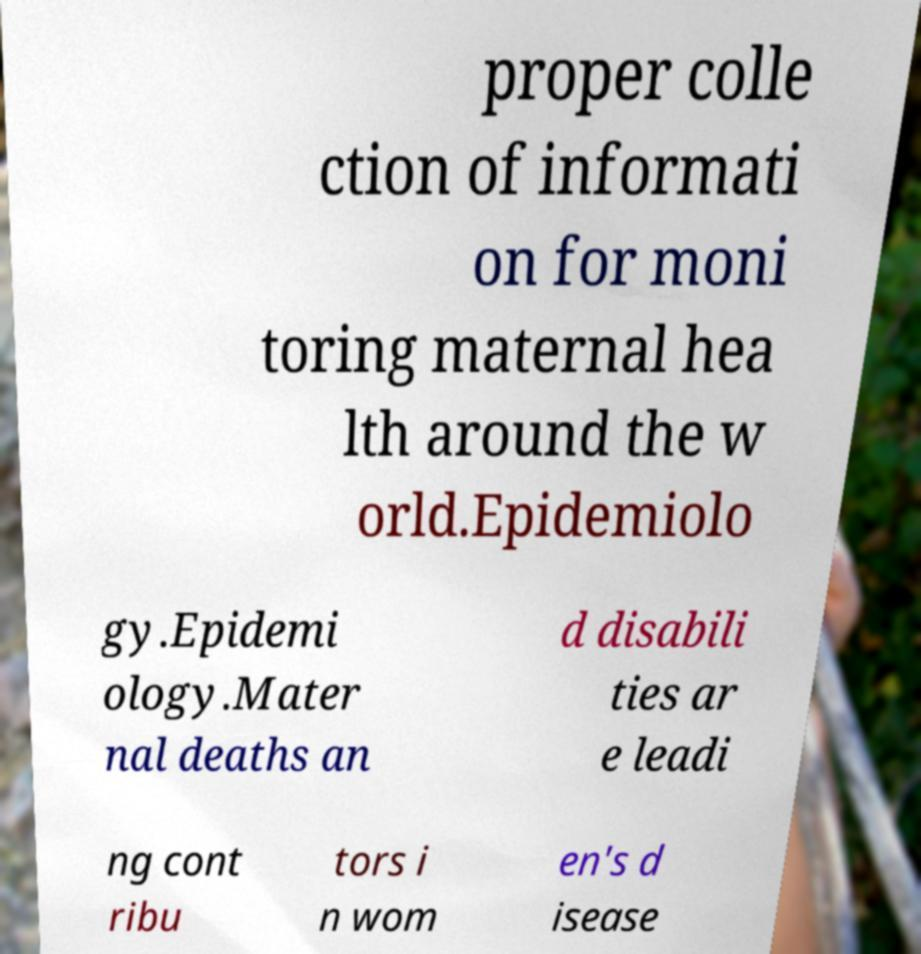For documentation purposes, I need the text within this image transcribed. Could you provide that? proper colle ction of informati on for moni toring maternal hea lth around the w orld.Epidemiolo gy.Epidemi ology.Mater nal deaths an d disabili ties ar e leadi ng cont ribu tors i n wom en's d isease 